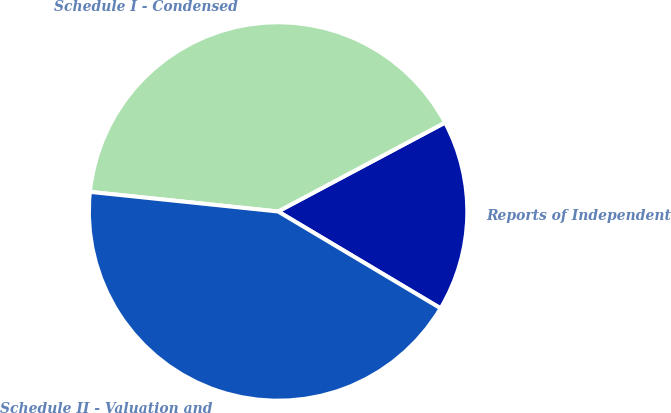<chart> <loc_0><loc_0><loc_500><loc_500><pie_chart><fcel>Reports of Independent<fcel>Schedule I - Condensed<fcel>Schedule II - Valuation and<nl><fcel>16.34%<fcel>40.56%<fcel>43.1%<nl></chart> 